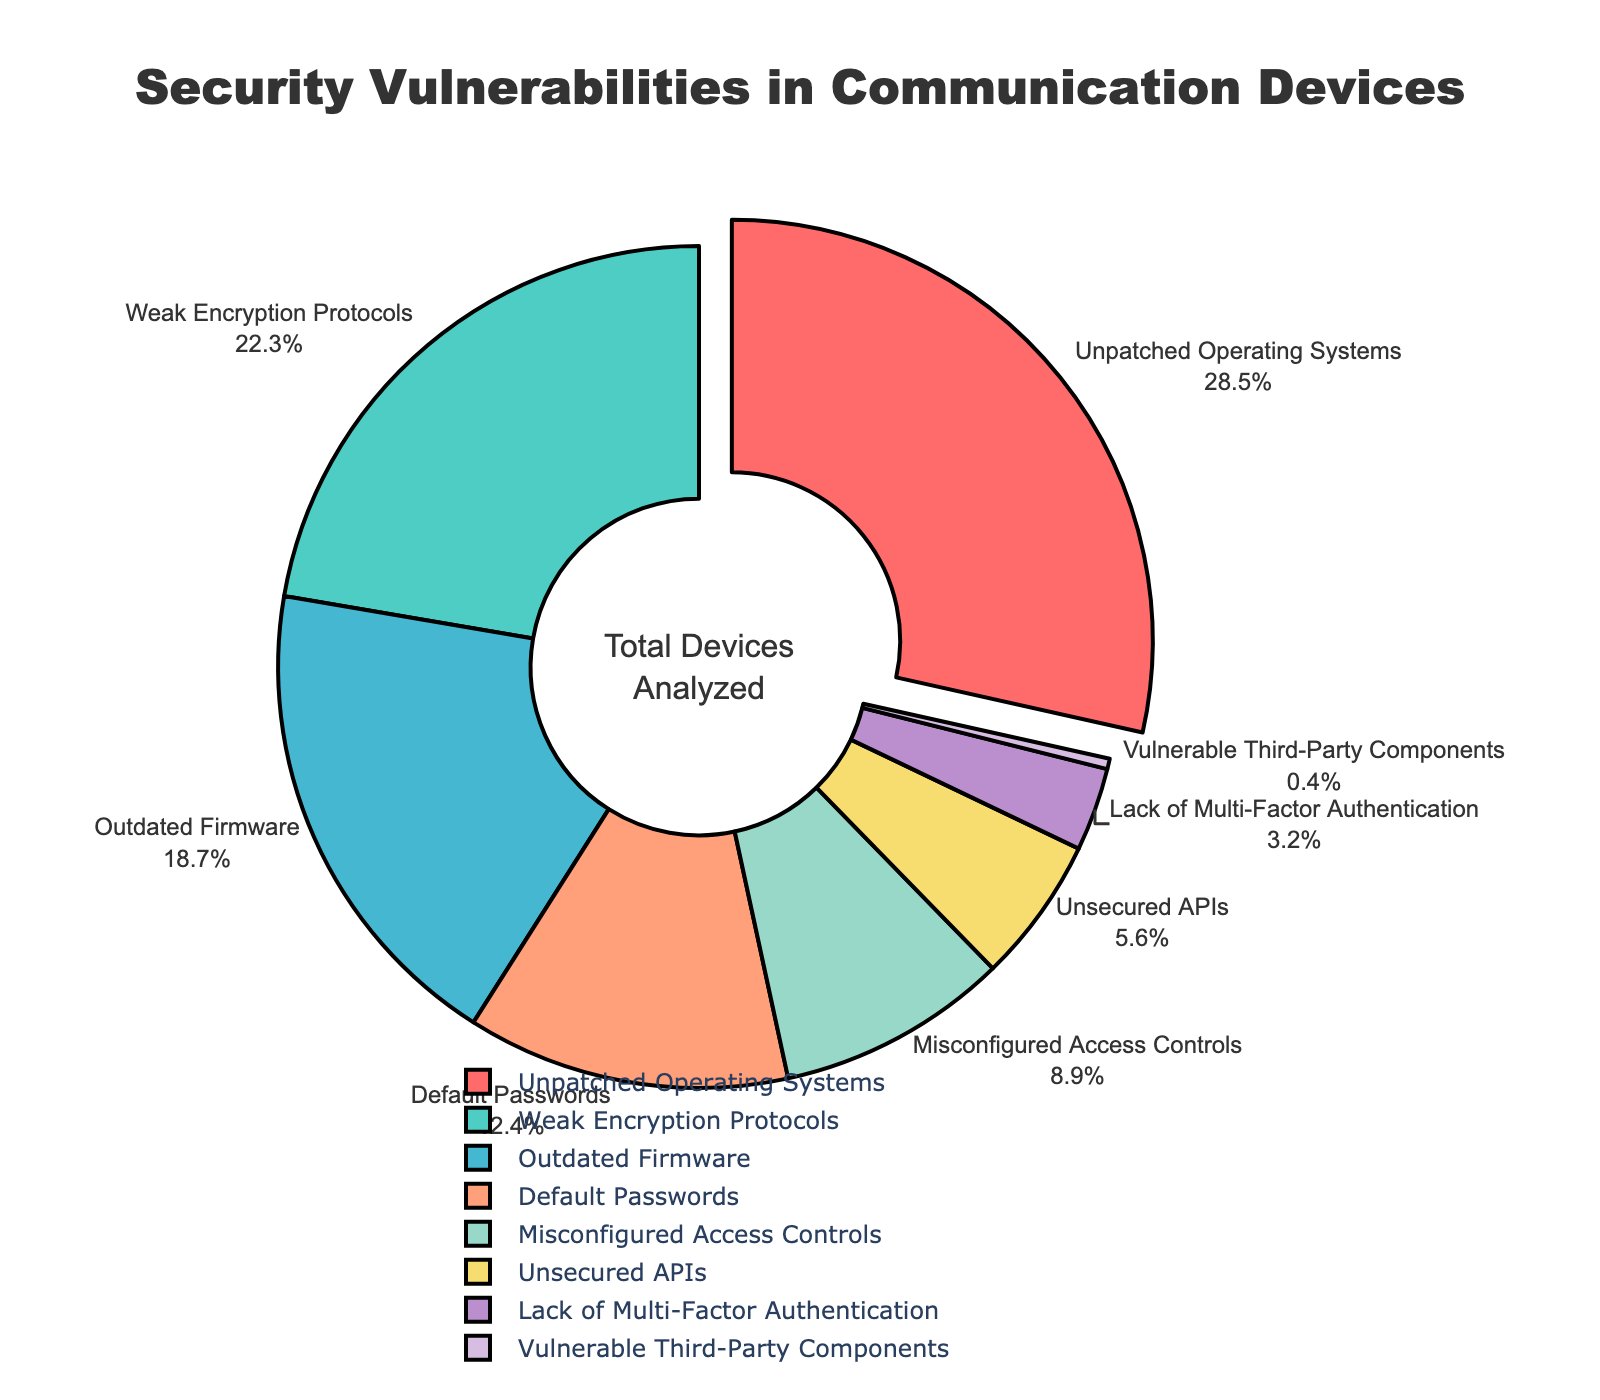Which device type has the highest percentage of security vulnerabilities? The pie chart visually emphasizes "Unpatched Operating Systems" by pulling this segment out and highlighting it. Additionally, the percentage value shown is 28.5%, which is higher than any other segment.
Answer: Unpatched Operating Systems How much more prevalent are "Weak Encryption Protocols" vulnerabilities compared to "Unsecured APIs"? The percentage for "Weak Encryption Protocols" is 22.3%, and for "Unsecured APIs", it is 5.6%. The difference is found by subtracting 5.6 from 22.3.
Answer: 16.7% Which vulnerability type makes up the smallest proportion of security vulnerabilities in communication devices? The smallest slice of the pie chart is labeled "Vulnerable Third-Party Components" with a percentage of 0.4%.
Answer: Vulnerable Third-Party Components What is the combined percentage of "Weak Encryption Protocols" and "Outdated Firmware" vulnerabilities? The percentage for "Weak Encryption Protocols" is 22.3% and for "Outdated Firmware" is 18.7%. Adding these two percentages together gives the combined value.
Answer: 41% Are there any vulnerability types with a percentage lower than 10%? If so, which ones? The pie chart shows that "Misconfigured Access Controls" (8.9%), "Unsecured APIs" (5.6%), "Lack of Multi-Factor Authentication" (3.2%), and "Vulnerable Third-Party Components" (0.4%) all have percentages lower than 10%.
Answer: Yes, Misconfigured Access Controls, Unsecured APIs, Lack of Multi-Factor Authentication, Vulnerable Third-Party Components Which vulnerabilities are represented with the color blue? By visually inspecting the colors in the pie chart and the corresponding labels, "Outdated Firmware" is represented with the color blue.
Answer: Outdated Firmware What is the total percentage of vulnerabilities represented by the top three types? The top three vulnerabilities are "Unpatched Operating Systems" (28.5%), "Weak Encryption Protocols" (22.3%), and "Outdated Firmware" (18.7%). Adding these percentages together gives the total.
Answer: 69.5% Which is more prevalent: "Default Passwords" or "Misconfigured Access Controls"? The percentage for "Default Passwords" is 12.4%, and for "Misconfigured Access Controls", it is 8.9%. Comparing these values shows that "Default Passwords" is more prevalent.
Answer: Default Passwords What portion of devices have at least one vulnerability related to either "Unsecured APIs" or "Lack of Multi-Factor Authentication"? The percentage of devices with "Unsecured APIs" is 5.6%, and with "Lack of Multi-Factor Authentication" is 3.2%. Adding these percentages together gives the total portion.
Answer: 8.8% 